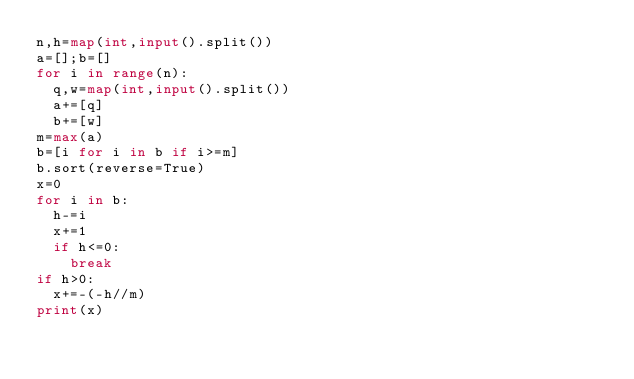Convert code to text. <code><loc_0><loc_0><loc_500><loc_500><_Python_>n,h=map(int,input().split())
a=[];b=[]
for i in range(n):
  q,w=map(int,input().split())
  a+=[q]
  b+=[w]
m=max(a)
b=[i for i in b if i>=m]
b.sort(reverse=True)
x=0
for i in b:
  h-=i
  x+=1
  if h<=0:
    break
if h>0:
  x+=-(-h//m)
print(x)</code> 